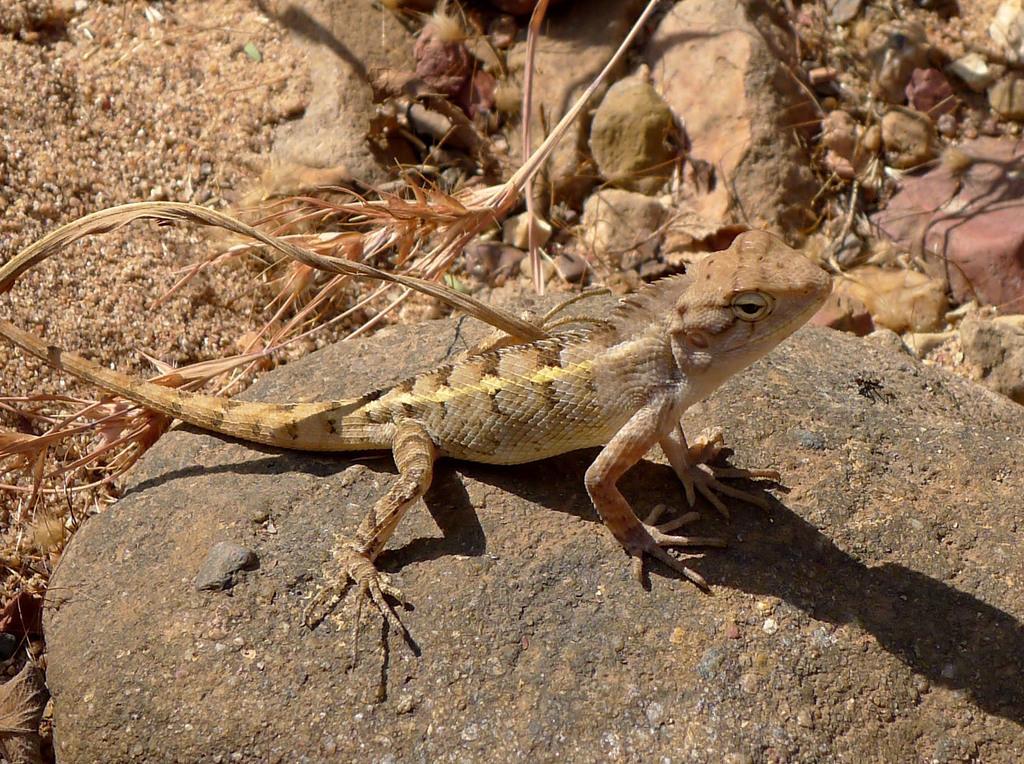In one or two sentences, can you explain what this image depicts? In this image I can see the reptile and the reptile is in cream and brown color. The reptile is on the stone, background I can see few stone and I can also see few dried leaves. 